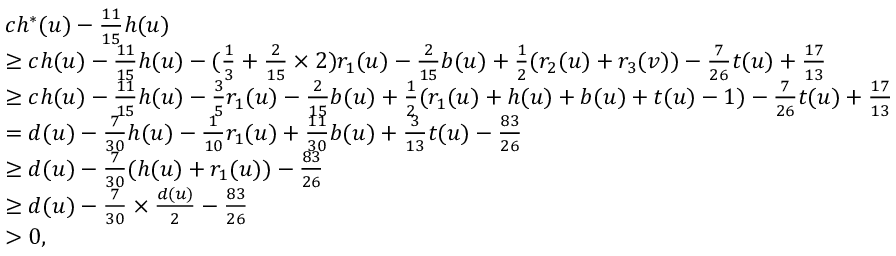<formula> <loc_0><loc_0><loc_500><loc_500>\begin{array} { r l } & { c h ^ { * } ( u ) - \frac { 1 1 } { 1 5 } h ( u ) } \\ & { \geq c h ( u ) - \frac { 1 1 } { 1 5 } h ( u ) - ( \frac { 1 } { 3 } + \frac { 2 } { 1 5 } \times 2 ) r _ { 1 } ( u ) - \frac { 2 } { 1 5 } b ( u ) + \frac { 1 } { 2 } ( r _ { 2 } ( u ) + r _ { 3 } ( v ) ) - \frac { 7 } { 2 6 } t ( u ) + \frac { 1 7 } { 1 3 } } \\ & { \geq c h ( u ) - \frac { 1 1 } { 1 5 } h ( u ) - \frac { 3 } { 5 } r _ { 1 } ( u ) - \frac { 2 } { 1 5 } b ( u ) + \frac { 1 } { 2 } ( r _ { 1 } ( u ) + h ( u ) + b ( u ) + t ( u ) - 1 ) - \frac { 7 } { 2 6 } t ( u ) + \frac { 1 7 } { 1 3 } } \\ & { = d ( u ) - \frac { 7 } { 3 0 } h ( u ) - \frac { 1 } { 1 0 } r _ { 1 } ( u ) + \frac { 1 1 } { 3 0 } b ( u ) + \frac { 3 } { 1 3 } t ( u ) - \frac { 8 3 } { 2 6 } } \\ & { \geq d ( u ) - \frac { 7 } { 3 0 } ( h ( u ) + r _ { 1 } ( u ) ) - \frac { 8 3 } { 2 6 } } \\ & { \geq d ( u ) - \frac { 7 } { 3 0 } \times \frac { d ( u ) } { 2 } - \frac { 8 3 } { 2 6 } } \\ & { > 0 , } \end{array}</formula> 